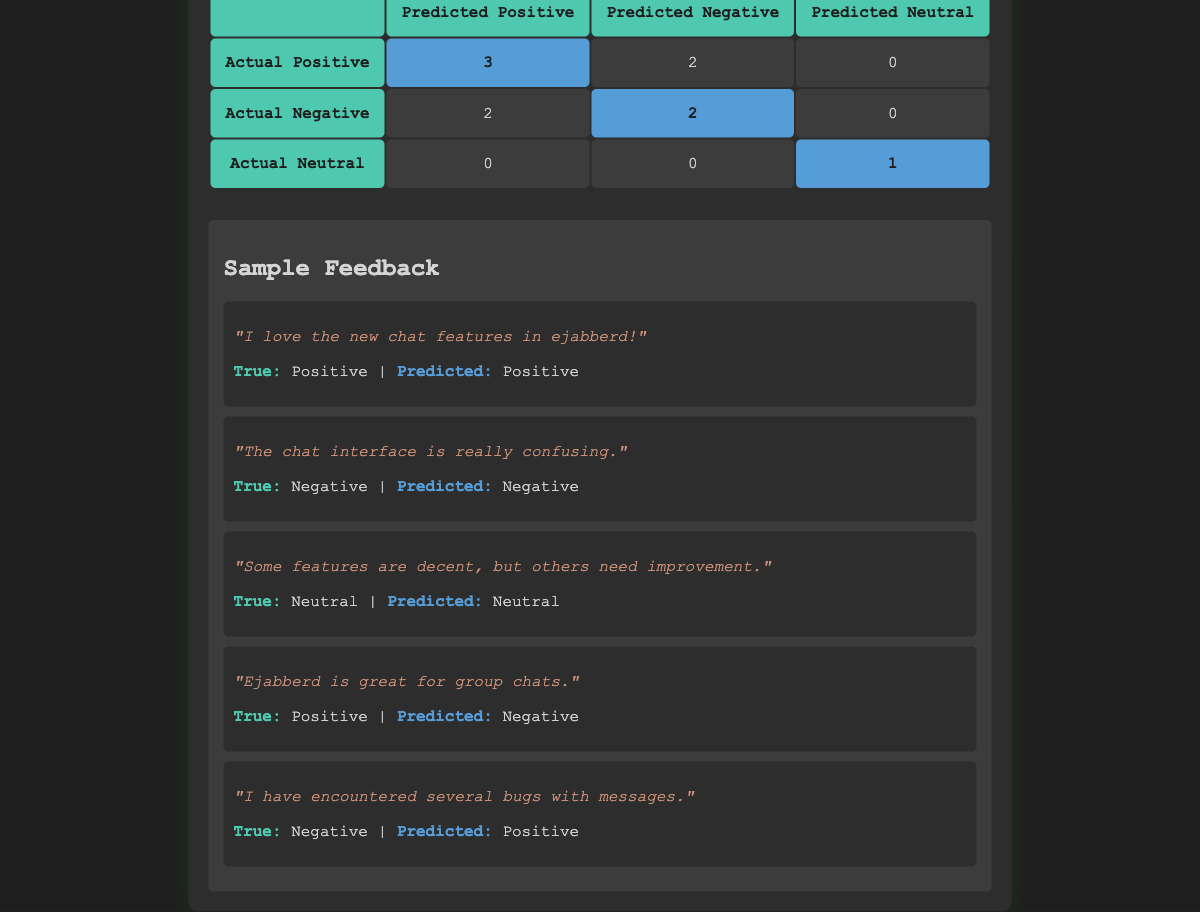What is the total count of actual positive feedback according to the confusion matrix? In the table, the "Actual Positive" row shows counts for "Predicted Positive," "Predicted Negative," and "Predicted Neutral." To find the total count, we can add these values: 3 (Predicted Positive) + 2 (Predicted Negative) + 0 (Predicted Neutral) = 5.
Answer: 5 How many feedback samples were incorrectly predicted as negative when they were actually positive? Looking at the "Actual Positive" row under "Predicted Negative," we see there are 2 samples. These indicate the number of actual positive feedback classifications that were mistakenly predicted as negative.
Answer: 2 What percentage of actual neutral feedback was accurately predicted? There is 1 actual neutral feedback sample correctly predicted as neutral (shown in the "Actual Neutral" row under "Predicted Neutral"). Since there is only 1 actual neutral feedback, the percentage is calculated as (1 / 1) * 100% = 100%.
Answer: 100% Did the model perform better on positive or negative feedback predictions? To evaluate performance, we can compare true positive and true negative counts. The true positives (Predicted Positive where True is Positive) are 3; true negatives (Predicted Negative where True is Negative) are 2. Therefore, the model performed better on positive feedback since 3 > 2.
Answer: Positive How many total predictions were made for negative feedback? For negative feedback, we can look at the "Actual Negative" row where counts are shown for "Predicted Positive," "Predicted Negative," and "Predicted Neutral." Adding these gives us 2 (Predicted Positive) + 2 (Predicted Negative) + 0 (Predicted Neutral) = 4 total predictions for negative feedback.
Answer: 4 What is the difference between the number of actual positive and actual negative feedback classifications? From the confusion matrix, we see there are 5 actual positive feedback counts (from the "Actual Positive" row) and 4 actual negative feedback counts (from the "Actual Negative" row). The difference is calculated by subtracting the two: 5 - 4 = 1.
Answer: 1 Is it correct to say that all actual neutral feedback was predicted correctly? Checking the "Actual Neutral" row, there is 1 feedback classified as neutral correctly (Predicted Neutral), and since there are no other actual neutral feedback samples, the statement is true.
Answer: Yes How would you summarize overall prediction performance for the neutral feedback? For neutral feedback, only 1 out of 1 sample was predicted correctly, leading to an accuracy of 100% for neutral predictions. This indicates that neutral feedback was classified accurately in all cases.
Answer: 100% Accurate 